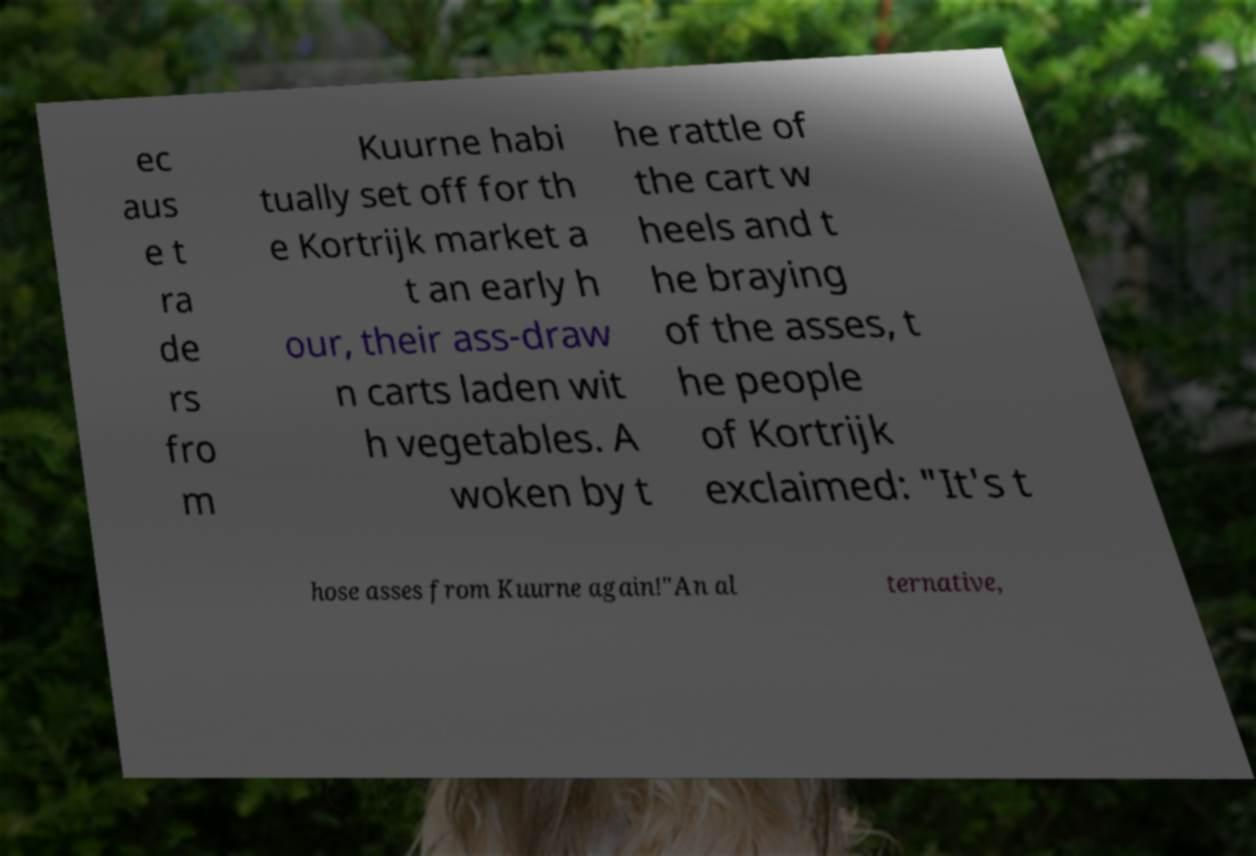Please identify and transcribe the text found in this image. ec aus e t ra de rs fro m Kuurne habi tually set off for th e Kortrijk market a t an early h our, their ass-draw n carts laden wit h vegetables. A woken by t he rattle of the cart w heels and t he braying of the asses, t he people of Kortrijk exclaimed: "It's t hose asses from Kuurne again!"An al ternative, 